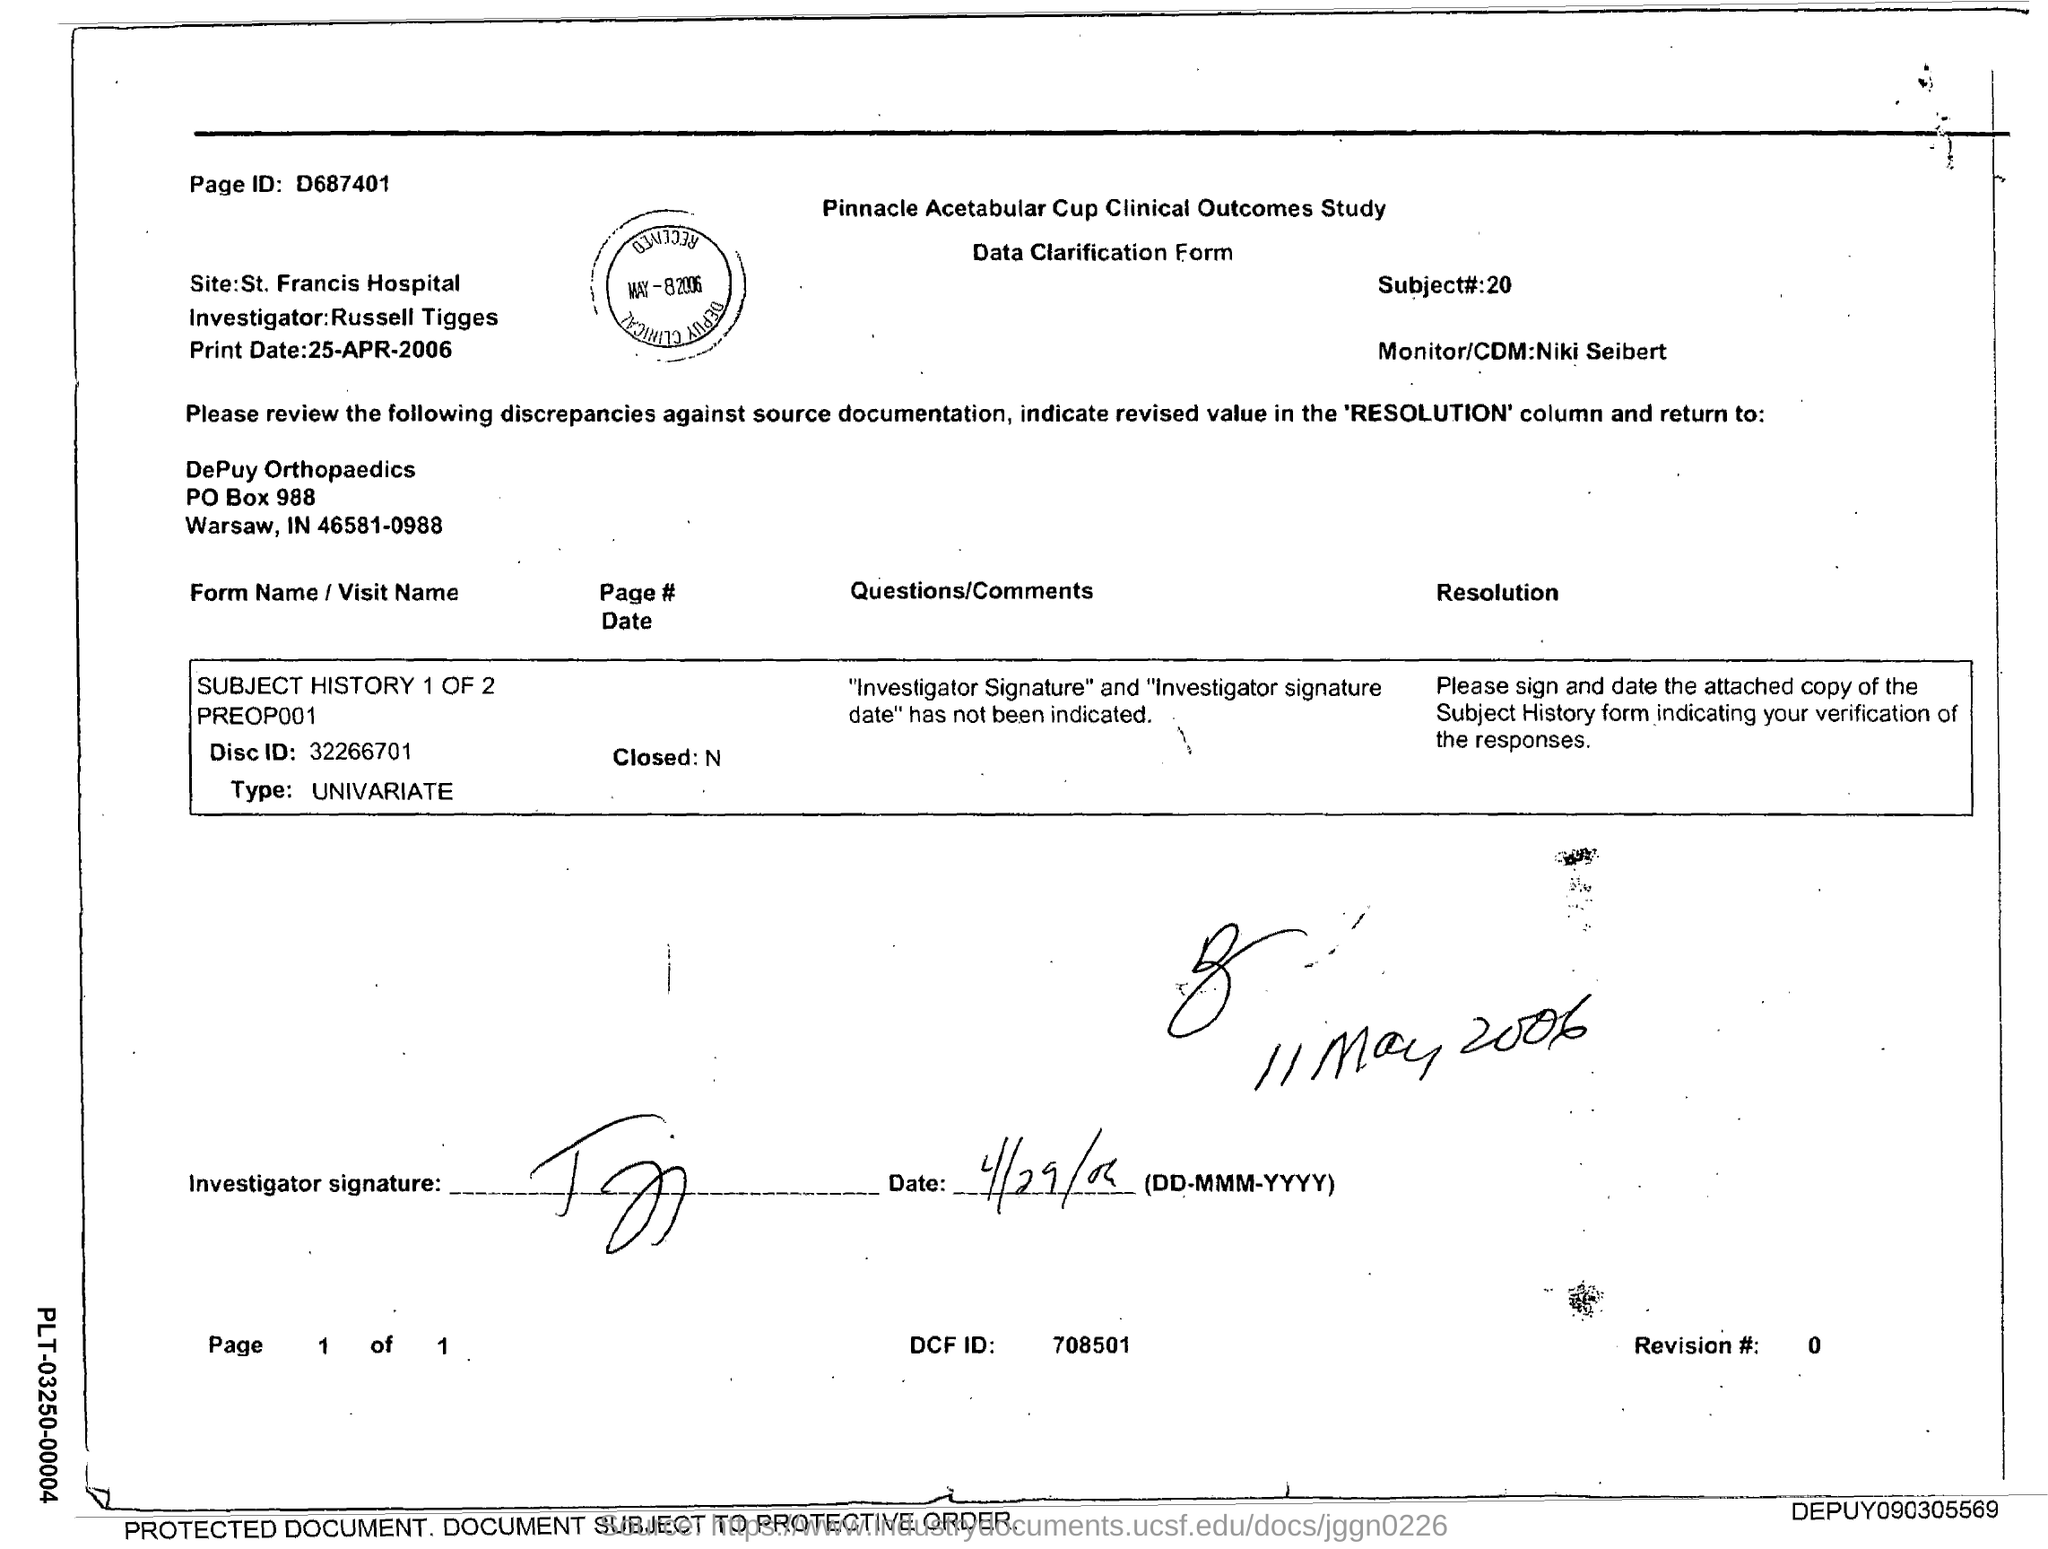Identify some key points in this picture. The name of the investigator is Russell Tigges. What is the revision number? It starts at 0 and goes up to infinity. The subject number is 20. Could you please provide the page ID? It is D687401... Thank you. 